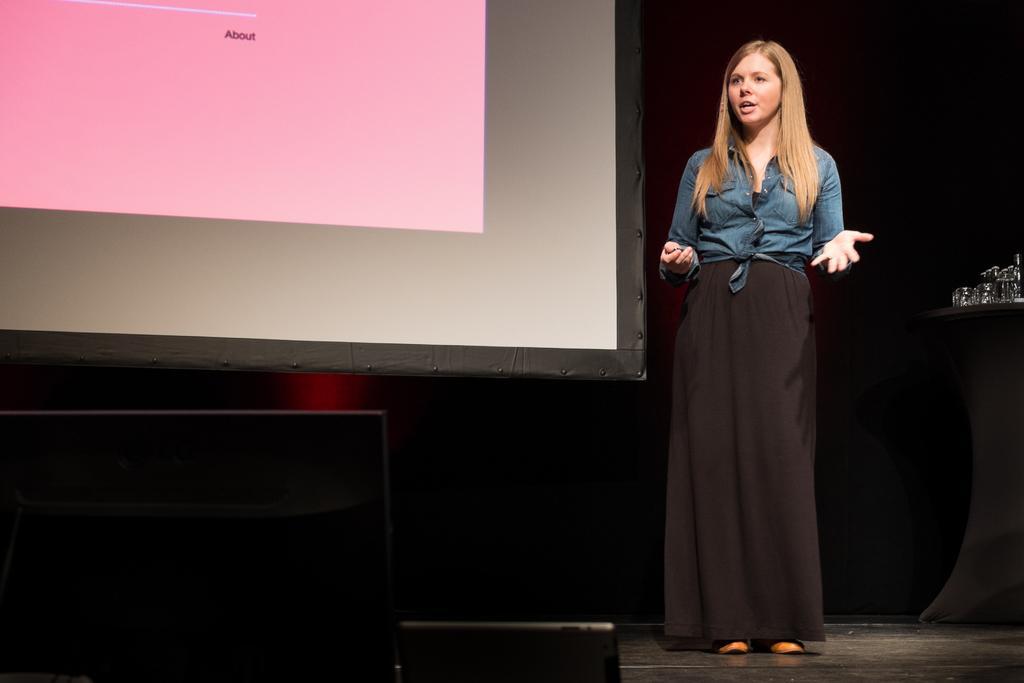Describe this image in one or two sentences. In this image, we can see a person standing. We can also see a table with some objects on the right. We can see the ground. We can see some black colored objects. We can see a projector screen and the background is blurred. 